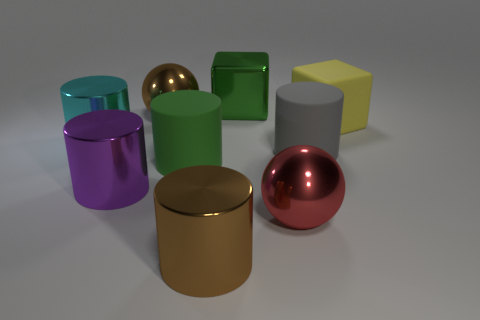Subtract all brown shiny cylinders. How many cylinders are left? 4 Add 1 large cyan blocks. How many objects exist? 10 Subtract all yellow cubes. How many cubes are left? 1 Subtract all balls. How many objects are left? 7 Add 6 big gray things. How many big gray things are left? 7 Add 3 small purple matte things. How many small purple matte things exist? 3 Subtract 1 cyan cylinders. How many objects are left? 8 Subtract all cyan cubes. Subtract all gray spheres. How many cubes are left? 2 Subtract all purple metallic cylinders. Subtract all rubber cylinders. How many objects are left? 6 